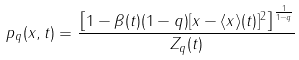<formula> <loc_0><loc_0><loc_500><loc_500>p _ { q } ( x , t ) = \frac { \left [ 1 - \beta ( t ) ( 1 - q ) [ x - \langle x \rangle ( t ) ] ^ { 2 } \right ] ^ { \frac { 1 } { 1 - q } } } { Z _ { q } ( t ) }</formula> 